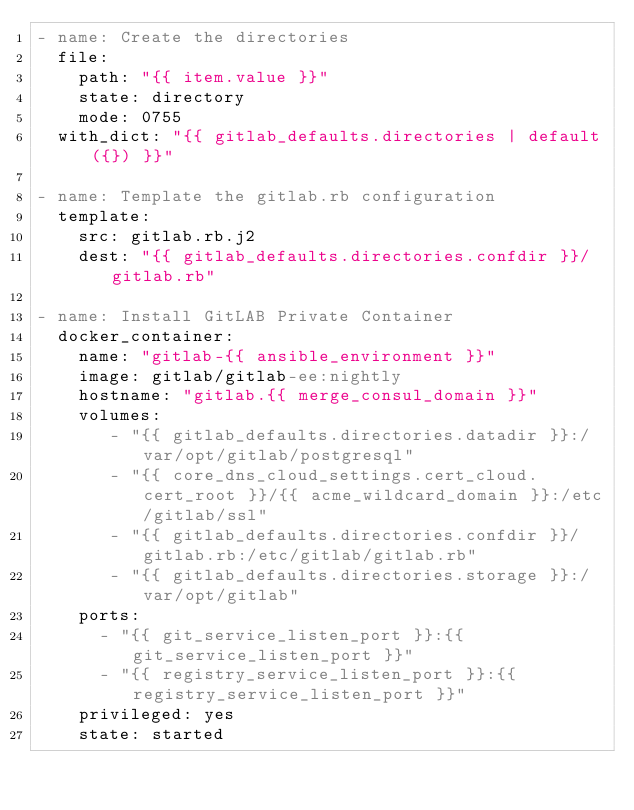<code> <loc_0><loc_0><loc_500><loc_500><_YAML_>- name: Create the directories
  file:
    path: "{{ item.value }}"
    state: directory
    mode: 0755
  with_dict: "{{ gitlab_defaults.directories | default({}) }}"

- name: Template the gitlab.rb configuration
  template:
    src: gitlab.rb.j2
    dest: "{{ gitlab_defaults.directories.confdir }}/gitlab.rb"

- name: Install GitLAB Private Container
  docker_container:
    name: "gitlab-{{ ansible_environment }}"
    image: gitlab/gitlab-ee:nightly
    hostname: "gitlab.{{ merge_consul_domain }}"
    volumes:
       - "{{ gitlab_defaults.directories.datadir }}:/var/opt/gitlab/postgresql"
       - "{{ core_dns_cloud_settings.cert_cloud.cert_root }}/{{ acme_wildcard_domain }}:/etc/gitlab/ssl"
       - "{{ gitlab_defaults.directories.confdir }}/gitlab.rb:/etc/gitlab/gitlab.rb"
       - "{{ gitlab_defaults.directories.storage }}:/var/opt/gitlab"
    ports:
      - "{{ git_service_listen_port }}:{{ git_service_listen_port }}"
      - "{{ registry_service_listen_port }}:{{ registry_service_listen_port }}"
    privileged: yes
    state: started</code> 